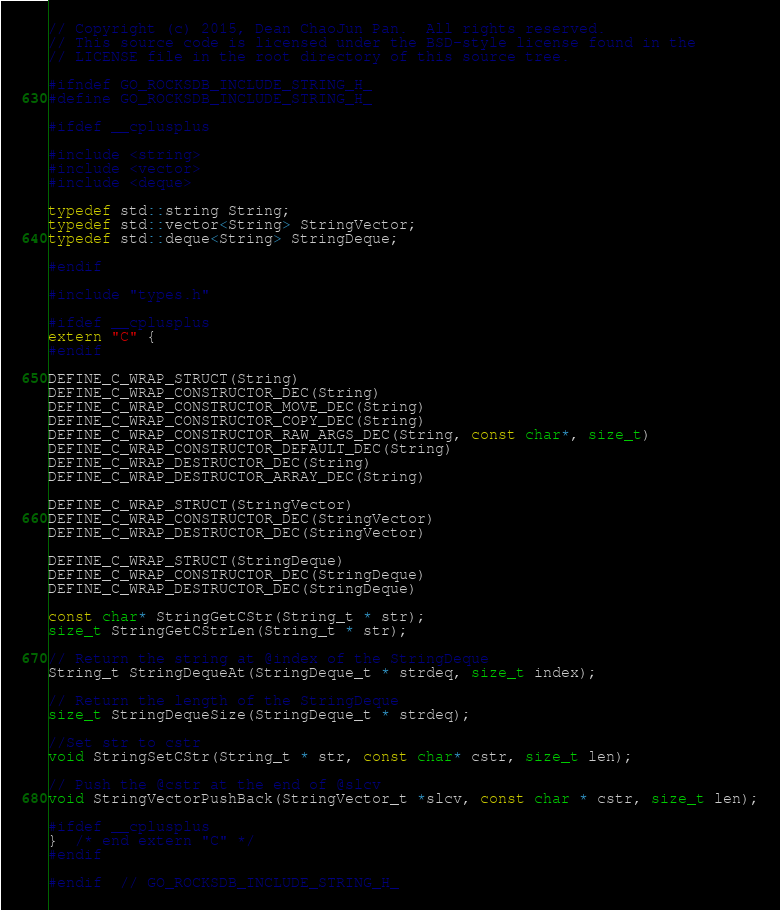<code> <loc_0><loc_0><loc_500><loc_500><_C_>// Copyright (c) 2015, Dean ChaoJun Pan.  All rights reserved.
// This source code is licensed under the BSD-style license found in the
// LICENSE file in the root directory of this source tree.

#ifndef GO_ROCKSDB_INCLUDE_STRING_H_
#define GO_ROCKSDB_INCLUDE_STRING_H_

#ifdef __cplusplus

#include <string>
#include <vector>
#include <deque>

typedef std::string String;
typedef std::vector<String> StringVector;
typedef std::deque<String> StringDeque;

#endif

#include "types.h"

#ifdef __cplusplus
extern "C" {
#endif

DEFINE_C_WRAP_STRUCT(String)
DEFINE_C_WRAP_CONSTRUCTOR_DEC(String)
DEFINE_C_WRAP_CONSTRUCTOR_MOVE_DEC(String)
DEFINE_C_WRAP_CONSTRUCTOR_COPY_DEC(String)
DEFINE_C_WRAP_CONSTRUCTOR_RAW_ARGS_DEC(String, const char*, size_t)
DEFINE_C_WRAP_CONSTRUCTOR_DEFAULT_DEC(String)
DEFINE_C_WRAP_DESTRUCTOR_DEC(String)
DEFINE_C_WRAP_DESTRUCTOR_ARRAY_DEC(String)

DEFINE_C_WRAP_STRUCT(StringVector)
DEFINE_C_WRAP_CONSTRUCTOR_DEC(StringVector)
DEFINE_C_WRAP_DESTRUCTOR_DEC(StringVector)

DEFINE_C_WRAP_STRUCT(StringDeque)
DEFINE_C_WRAP_CONSTRUCTOR_DEC(StringDeque)
DEFINE_C_WRAP_DESTRUCTOR_DEC(StringDeque)

const char* StringGetCStr(String_t * str);
size_t StringGetCStrLen(String_t * str);

// Return the string at @index of the StringDeque
String_t StringDequeAt(StringDeque_t * strdeq, size_t index);

// Return the length of the StringDeque
size_t StringDequeSize(StringDeque_t * strdeq);

//Set str to cstr
void StringSetCStr(String_t * str, const char* cstr, size_t len);

// Push the @cstr at the end of @slcv
void StringVectorPushBack(StringVector_t *slcv, const char * cstr, size_t len);

#ifdef __cplusplus
}  /* end extern "C" */
#endif

#endif  // GO_ROCKSDB_INCLUDE_STRING_H_
</code> 